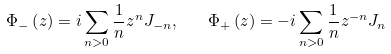Convert formula to latex. <formula><loc_0><loc_0><loc_500><loc_500>\Phi _ { - } \left ( z \right ) = i \sum _ { n > 0 } \frac { 1 } { n } z ^ { n } J _ { - n } , \quad \Phi _ { + } \left ( z \right ) = - i \sum _ { n > 0 } \frac { 1 } { n } z ^ { - n } J _ { n }</formula> 